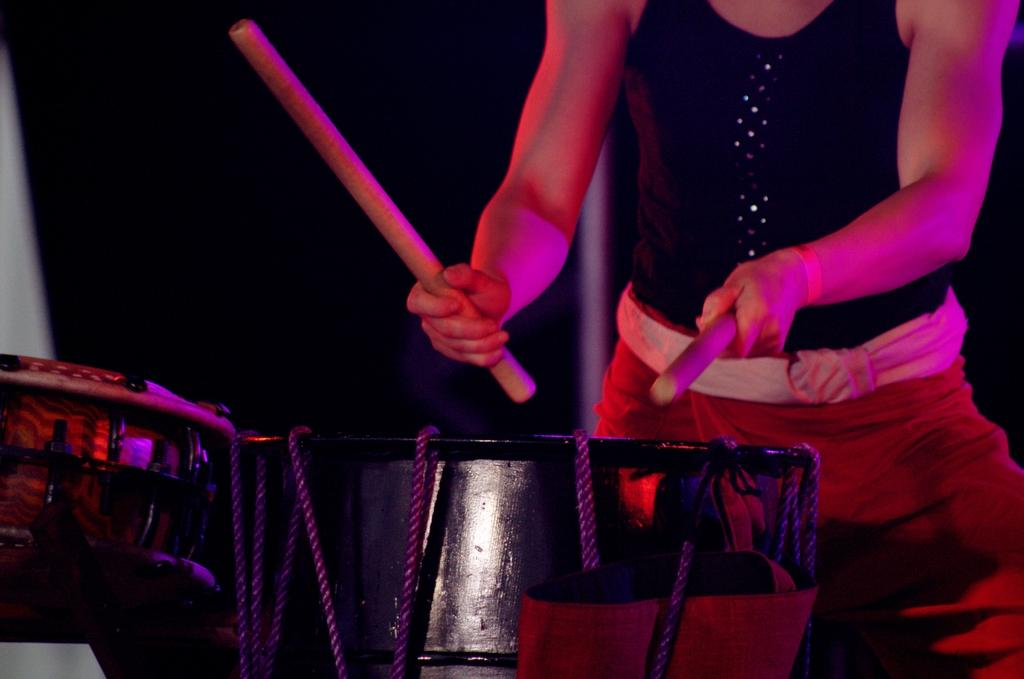Who is the main subject in the image? There is a woman in the image. What is the woman doing in the image? The woman is playing drums. How is the woman playing the drums? The woman is using sticks in her hands to play the drums. How many ants can be seen crawling on the woman's drumsticks in the image? There are no ants present in the image, so it is not possible to determine how many ants might be crawling on the drumsticks. 